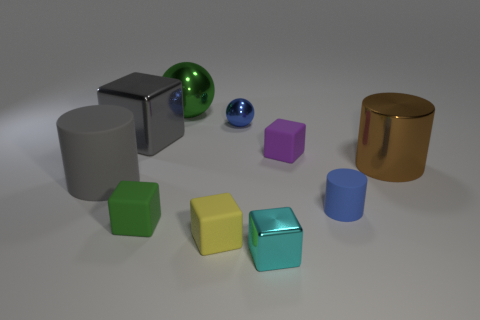Subtract all rubber cylinders. How many cylinders are left? 1 Subtract all cyan blocks. How many blocks are left? 4 Subtract 5 cubes. How many cubes are left? 0 Subtract all spheres. How many objects are left? 8 Subtract all big gray cubes. Subtract all tiny yellow objects. How many objects are left? 8 Add 6 big gray cubes. How many big gray cubes are left? 7 Add 10 gray metal spheres. How many gray metal spheres exist? 10 Subtract 0 red cubes. How many objects are left? 10 Subtract all green cubes. Subtract all purple cylinders. How many cubes are left? 4 